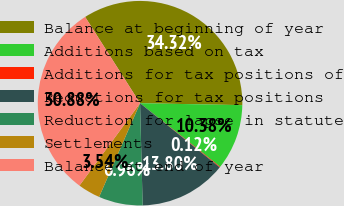Convert chart to OTSL. <chart><loc_0><loc_0><loc_500><loc_500><pie_chart><fcel>Balance at beginning of year<fcel>Additions based on tax<fcel>Additions for tax positions of<fcel>Reductions for tax positions<fcel>Reduction for lapse in statute<fcel>Settlements<fcel>Balance at end of year<nl><fcel>34.32%<fcel>10.38%<fcel>0.12%<fcel>13.8%<fcel>6.96%<fcel>3.54%<fcel>30.88%<nl></chart> 